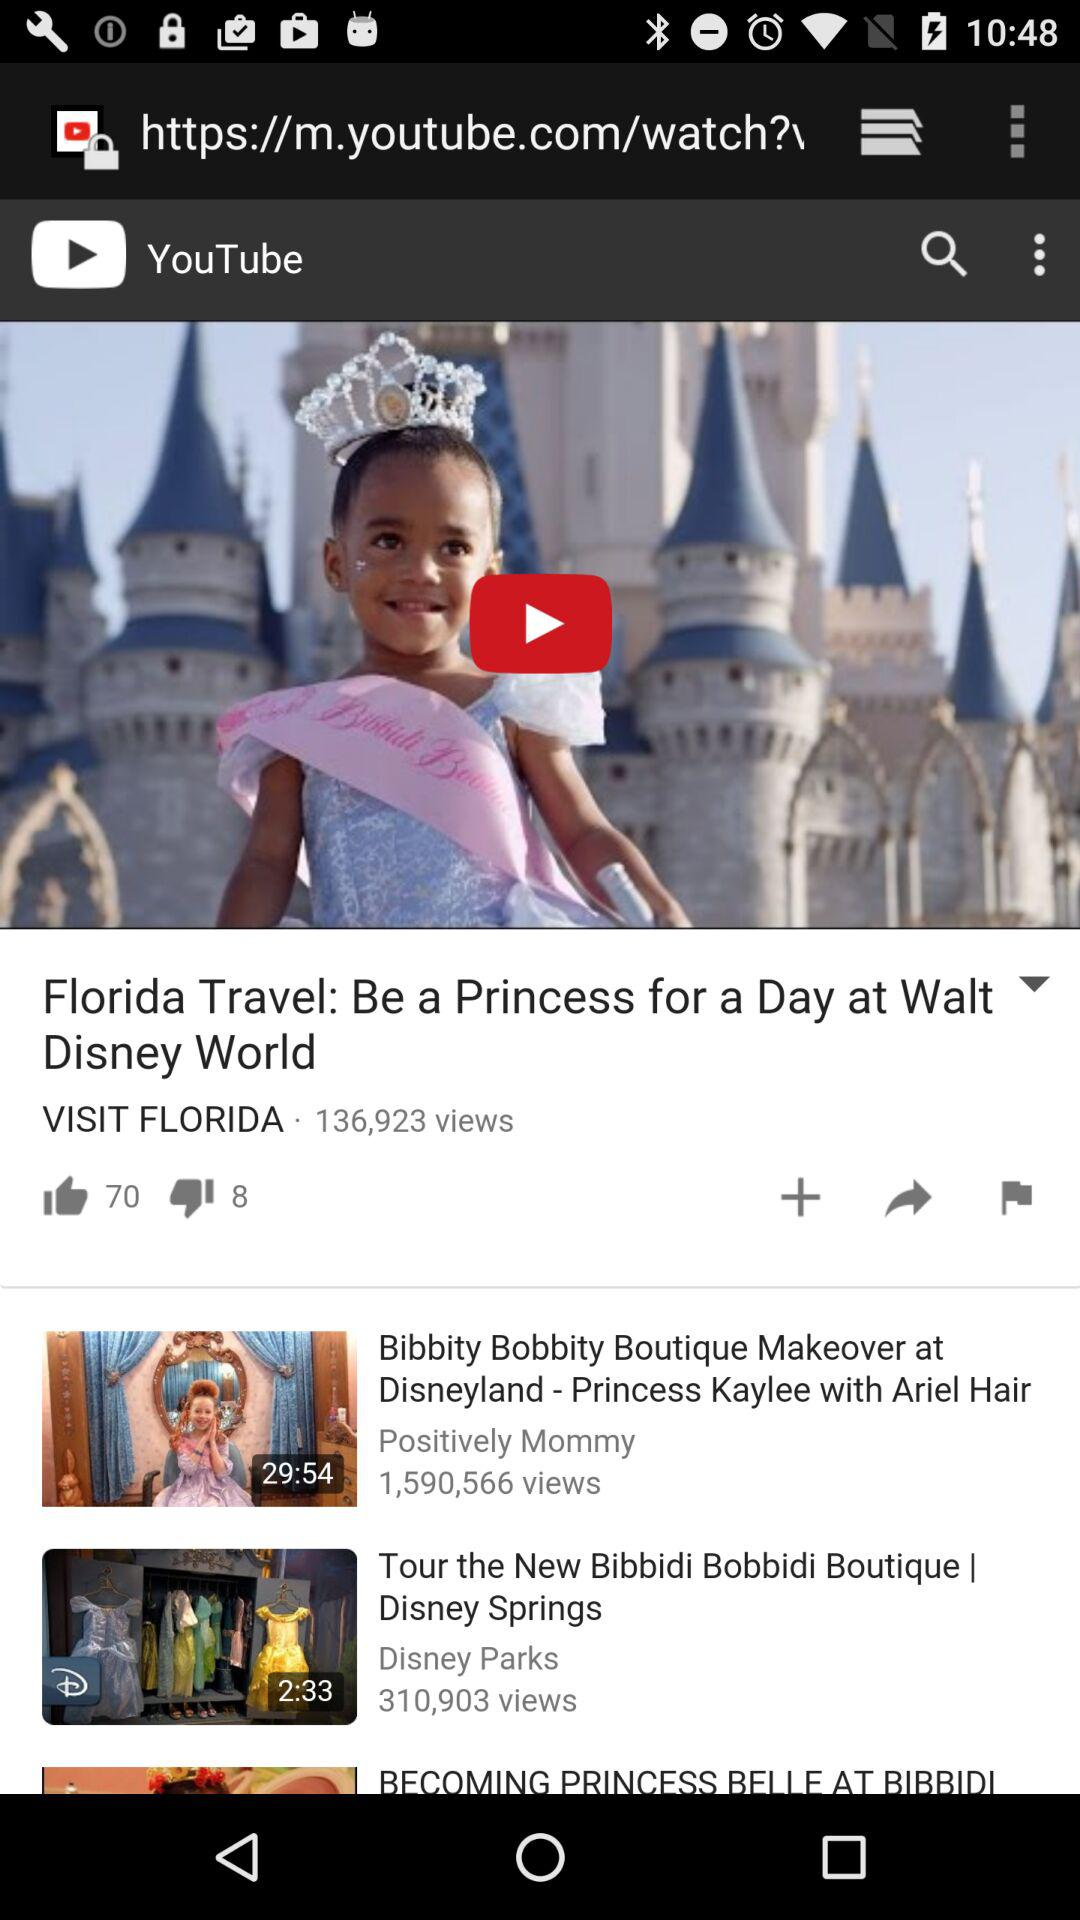How many views are there of the "Florida Travel" video? There are 136,923 views. 